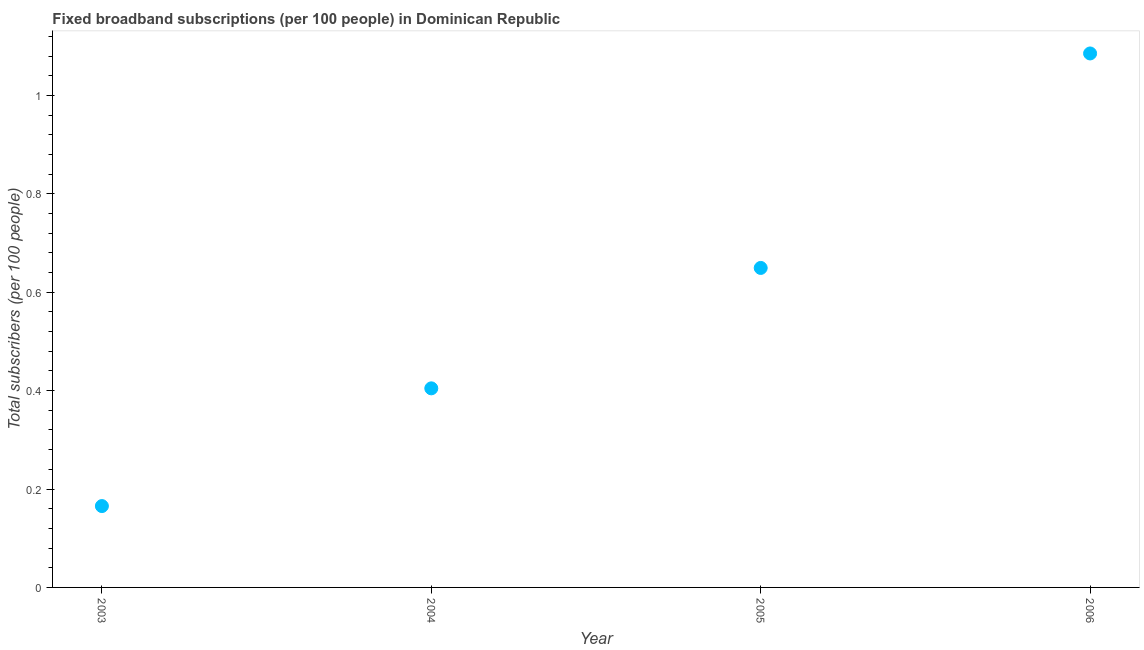What is the total number of fixed broadband subscriptions in 2005?
Your response must be concise. 0.65. Across all years, what is the maximum total number of fixed broadband subscriptions?
Your answer should be compact. 1.09. Across all years, what is the minimum total number of fixed broadband subscriptions?
Your answer should be compact. 0.17. What is the sum of the total number of fixed broadband subscriptions?
Provide a short and direct response. 2.3. What is the difference between the total number of fixed broadband subscriptions in 2004 and 2005?
Provide a succinct answer. -0.24. What is the average total number of fixed broadband subscriptions per year?
Provide a succinct answer. 0.58. What is the median total number of fixed broadband subscriptions?
Make the answer very short. 0.53. In how many years, is the total number of fixed broadband subscriptions greater than 0.4 ?
Ensure brevity in your answer.  3. What is the ratio of the total number of fixed broadband subscriptions in 2003 to that in 2005?
Ensure brevity in your answer.  0.25. Is the total number of fixed broadband subscriptions in 2004 less than that in 2006?
Make the answer very short. Yes. What is the difference between the highest and the second highest total number of fixed broadband subscriptions?
Provide a short and direct response. 0.44. What is the difference between the highest and the lowest total number of fixed broadband subscriptions?
Your answer should be very brief. 0.92. Does the total number of fixed broadband subscriptions monotonically increase over the years?
Your response must be concise. Yes. How many dotlines are there?
Provide a short and direct response. 1. How many years are there in the graph?
Keep it short and to the point. 4. Does the graph contain any zero values?
Provide a short and direct response. No. Does the graph contain grids?
Your response must be concise. No. What is the title of the graph?
Keep it short and to the point. Fixed broadband subscriptions (per 100 people) in Dominican Republic. What is the label or title of the Y-axis?
Your response must be concise. Total subscribers (per 100 people). What is the Total subscribers (per 100 people) in 2003?
Ensure brevity in your answer.  0.17. What is the Total subscribers (per 100 people) in 2004?
Offer a terse response. 0.4. What is the Total subscribers (per 100 people) in 2005?
Your answer should be very brief. 0.65. What is the Total subscribers (per 100 people) in 2006?
Your answer should be very brief. 1.09. What is the difference between the Total subscribers (per 100 people) in 2003 and 2004?
Offer a very short reply. -0.24. What is the difference between the Total subscribers (per 100 people) in 2003 and 2005?
Offer a terse response. -0.48. What is the difference between the Total subscribers (per 100 people) in 2003 and 2006?
Provide a succinct answer. -0.92. What is the difference between the Total subscribers (per 100 people) in 2004 and 2005?
Ensure brevity in your answer.  -0.24. What is the difference between the Total subscribers (per 100 people) in 2004 and 2006?
Ensure brevity in your answer.  -0.68. What is the difference between the Total subscribers (per 100 people) in 2005 and 2006?
Offer a terse response. -0.44. What is the ratio of the Total subscribers (per 100 people) in 2003 to that in 2004?
Make the answer very short. 0.41. What is the ratio of the Total subscribers (per 100 people) in 2003 to that in 2005?
Your answer should be very brief. 0.26. What is the ratio of the Total subscribers (per 100 people) in 2003 to that in 2006?
Ensure brevity in your answer.  0.15. What is the ratio of the Total subscribers (per 100 people) in 2004 to that in 2005?
Give a very brief answer. 0.62. What is the ratio of the Total subscribers (per 100 people) in 2004 to that in 2006?
Offer a very short reply. 0.37. What is the ratio of the Total subscribers (per 100 people) in 2005 to that in 2006?
Provide a short and direct response. 0.6. 